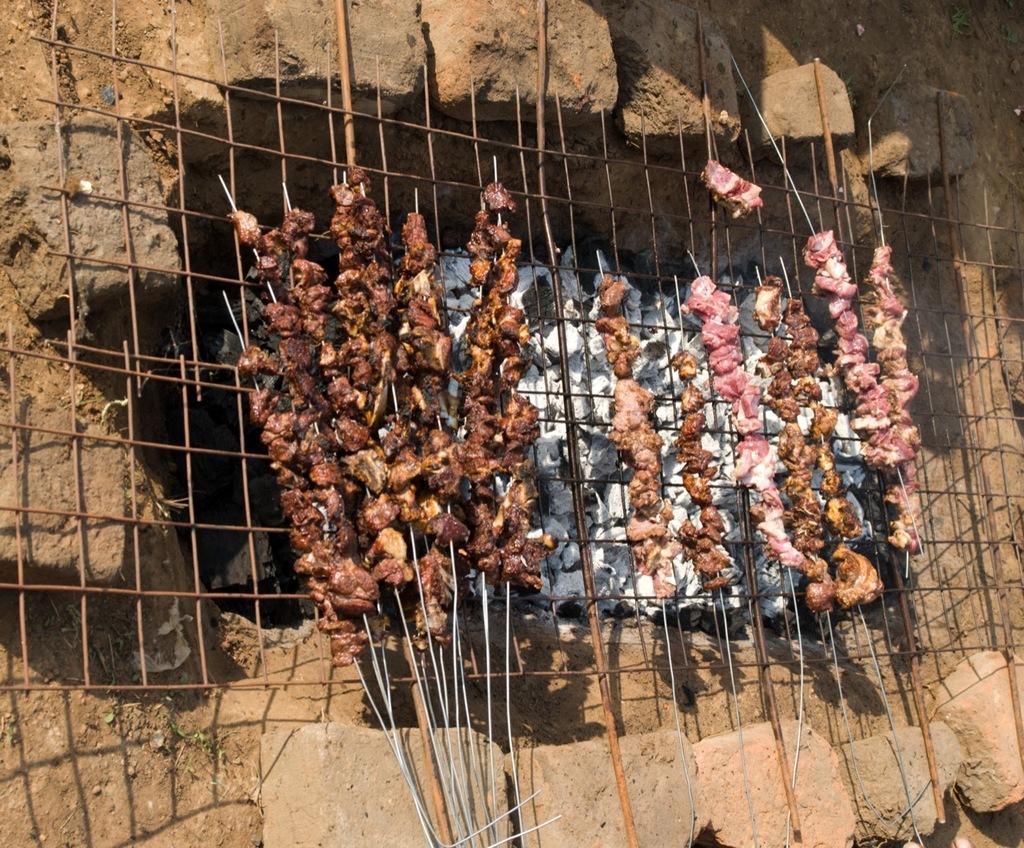Could you give a brief overview of what you see in this image? This image is taken outdoors. At the bottom of the image there is a ground and there are a few bricks and stones. In the middle of the image there is a mesh and there is a barbecue. There are a few meet pieces and there is ash. 